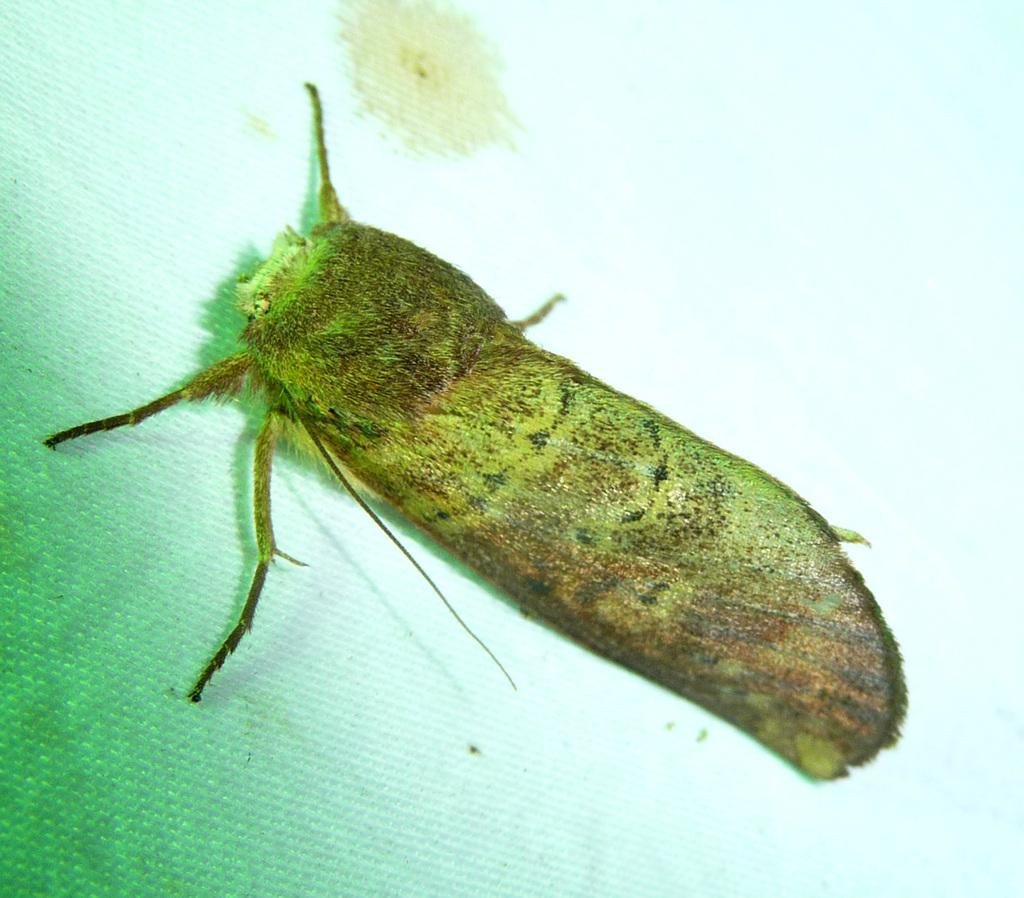What type of creature can be seen in the image? There is an insect in the image. How many tents are set up in the image? There are no tents present in the image; it only features an insect. How many bikes can be seen in the image? There are no bikes present in the image; it only features an insect. 